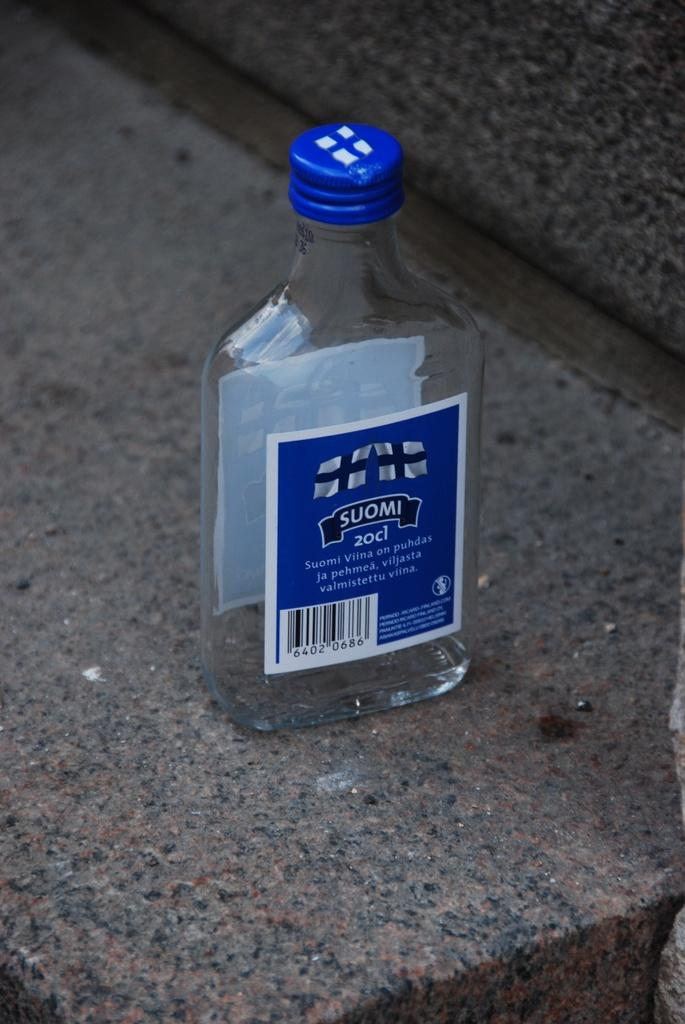<image>
Offer a succinct explanation of the picture presented. The empty bottle shown at one point has 20cl of liquid in it. 